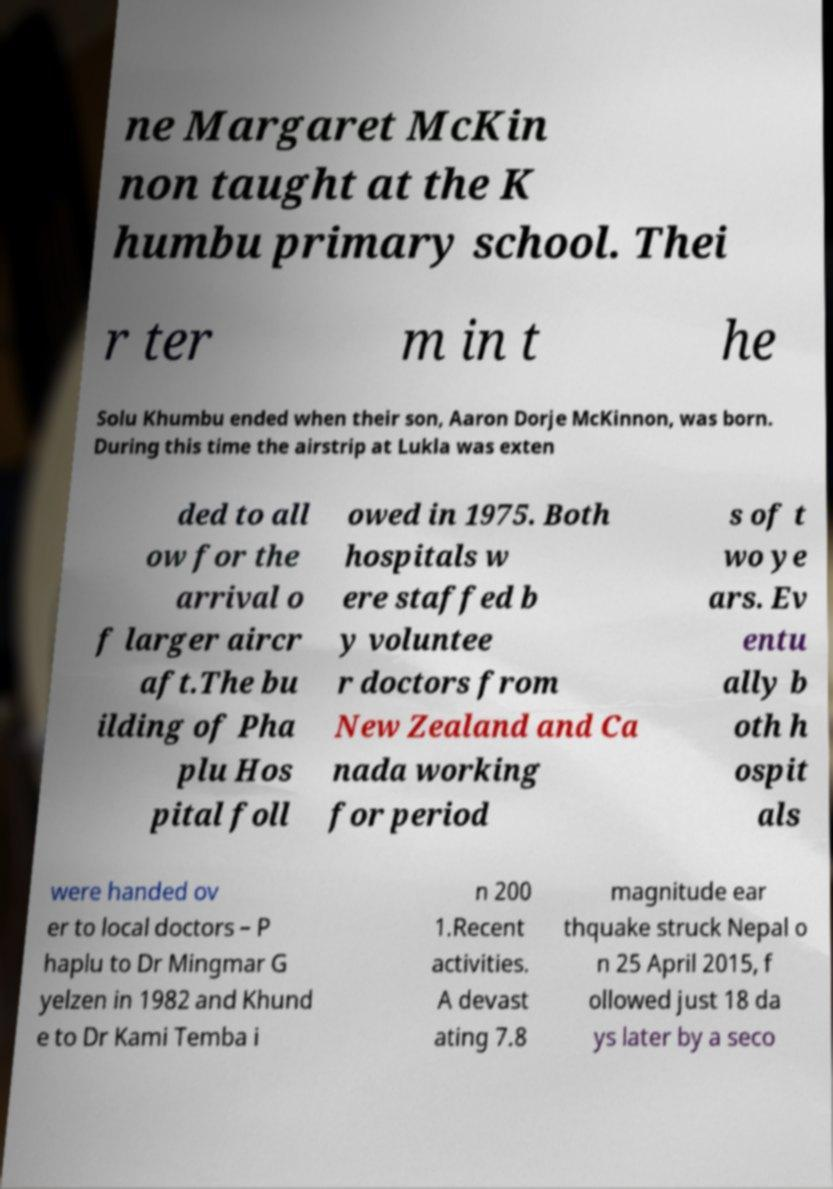Could you assist in decoding the text presented in this image and type it out clearly? ne Margaret McKin non taught at the K humbu primary school. Thei r ter m in t he Solu Khumbu ended when their son, Aaron Dorje McKinnon, was born. During this time the airstrip at Lukla was exten ded to all ow for the arrival o f larger aircr aft.The bu ilding of Pha plu Hos pital foll owed in 1975. Both hospitals w ere staffed b y voluntee r doctors from New Zealand and Ca nada working for period s of t wo ye ars. Ev entu ally b oth h ospit als were handed ov er to local doctors – P haplu to Dr Mingmar G yelzen in 1982 and Khund e to Dr Kami Temba i n 200 1.Recent activities. A devast ating 7.8 magnitude ear thquake struck Nepal o n 25 April 2015, f ollowed just 18 da ys later by a seco 